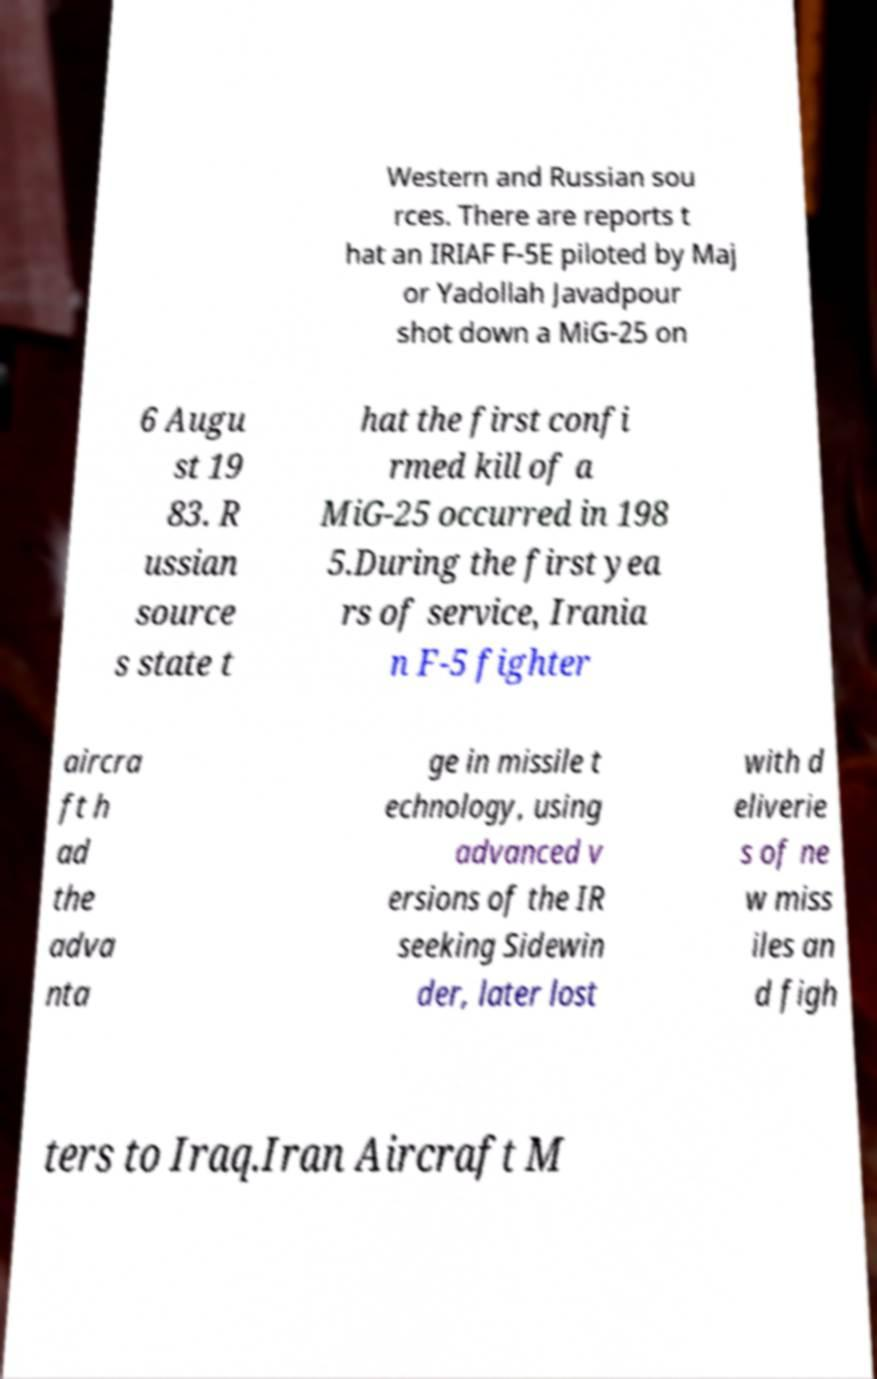There's text embedded in this image that I need extracted. Can you transcribe it verbatim? Western and Russian sou rces. There are reports t hat an IRIAF F-5E piloted by Maj or Yadollah Javadpour shot down a MiG-25 on 6 Augu st 19 83. R ussian source s state t hat the first confi rmed kill of a MiG-25 occurred in 198 5.During the first yea rs of service, Irania n F-5 fighter aircra ft h ad the adva nta ge in missile t echnology, using advanced v ersions of the IR seeking Sidewin der, later lost with d eliverie s of ne w miss iles an d figh ters to Iraq.Iran Aircraft M 